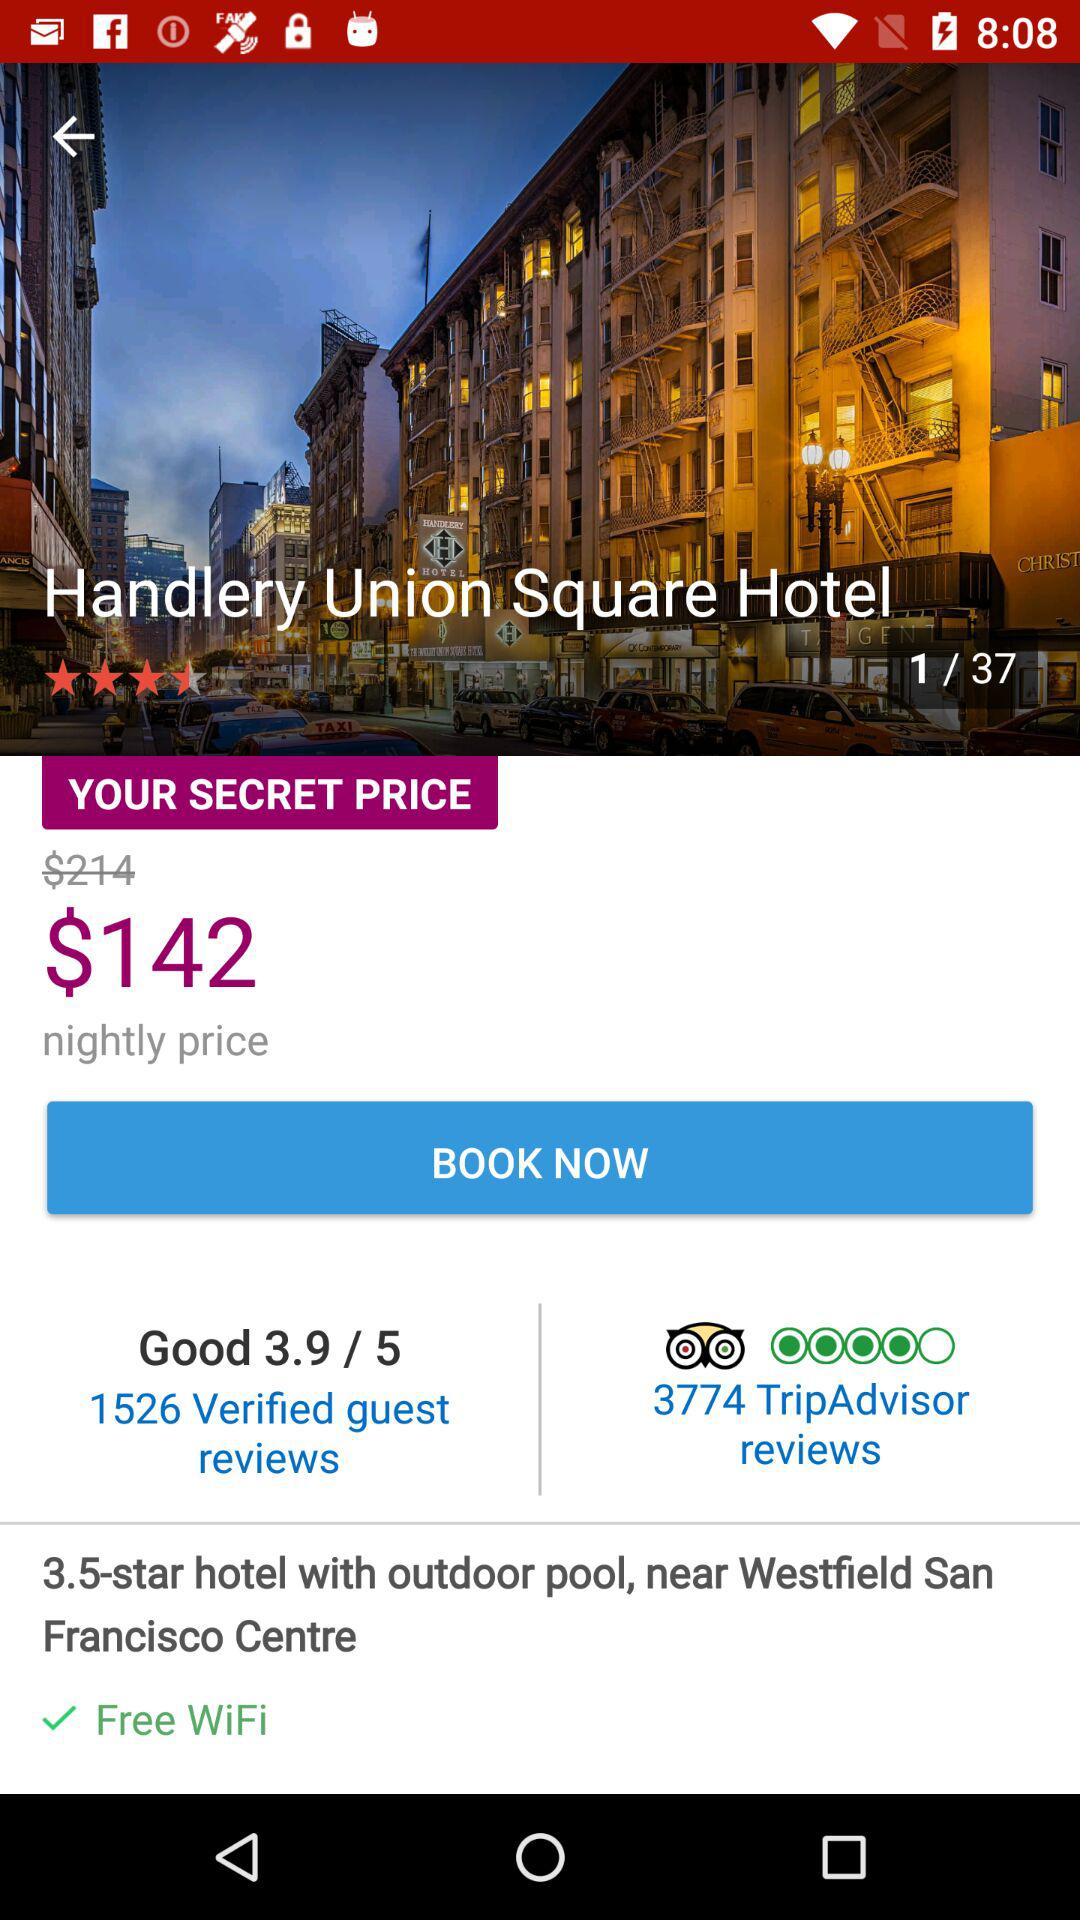What was the original booking price of a hotel room? The original booking price of a hotel room was $214. 